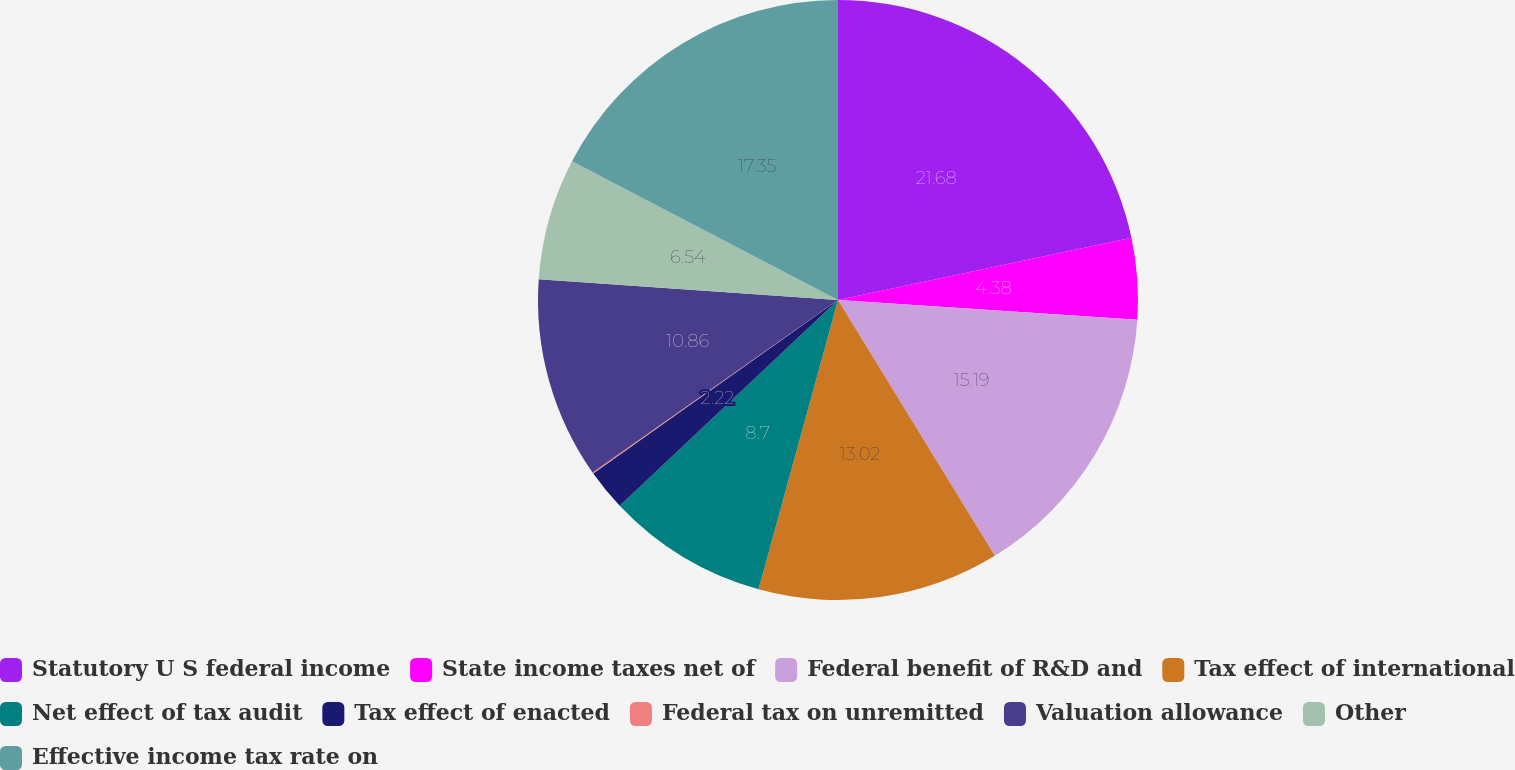Convert chart. <chart><loc_0><loc_0><loc_500><loc_500><pie_chart><fcel>Statutory U S federal income<fcel>State income taxes net of<fcel>Federal benefit of R&D and<fcel>Tax effect of international<fcel>Net effect of tax audit<fcel>Tax effect of enacted<fcel>Federal tax on unremitted<fcel>Valuation allowance<fcel>Other<fcel>Effective income tax rate on<nl><fcel>21.67%<fcel>4.38%<fcel>15.19%<fcel>13.02%<fcel>8.7%<fcel>2.22%<fcel>0.06%<fcel>10.86%<fcel>6.54%<fcel>17.35%<nl></chart> 